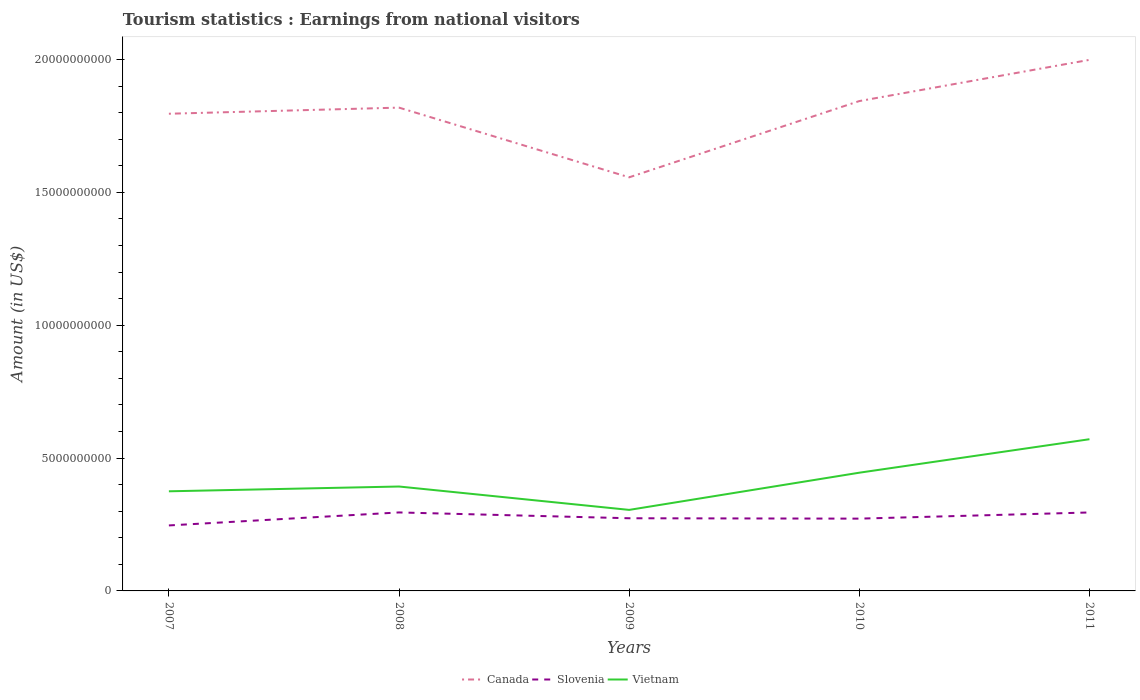How many different coloured lines are there?
Your answer should be very brief. 3. Is the number of lines equal to the number of legend labels?
Your answer should be very brief. Yes. Across all years, what is the maximum earnings from national visitors in Vietnam?
Your answer should be very brief. 3.05e+09. What is the total earnings from national visitors in Canada in the graph?
Offer a terse response. -4.77e+08. What is the difference between the highest and the second highest earnings from national visitors in Vietnam?
Your response must be concise. 2.66e+09. What is the difference between the highest and the lowest earnings from national visitors in Canada?
Give a very brief answer. 3. Is the earnings from national visitors in Vietnam strictly greater than the earnings from national visitors in Canada over the years?
Your answer should be very brief. Yes. How many lines are there?
Your answer should be very brief. 3. Are the values on the major ticks of Y-axis written in scientific E-notation?
Make the answer very short. No. What is the title of the graph?
Your answer should be very brief. Tourism statistics : Earnings from national visitors. Does "Mali" appear as one of the legend labels in the graph?
Offer a very short reply. No. What is the label or title of the X-axis?
Give a very brief answer. Years. What is the label or title of the Y-axis?
Your answer should be very brief. Amount (in US$). What is the Amount (in US$) in Canada in 2007?
Your answer should be compact. 1.80e+1. What is the Amount (in US$) of Slovenia in 2007?
Keep it short and to the point. 2.46e+09. What is the Amount (in US$) in Vietnam in 2007?
Give a very brief answer. 3.75e+09. What is the Amount (in US$) in Canada in 2008?
Your answer should be very brief. 1.82e+1. What is the Amount (in US$) in Slovenia in 2008?
Provide a succinct answer. 2.95e+09. What is the Amount (in US$) in Vietnam in 2008?
Offer a terse response. 3.93e+09. What is the Amount (in US$) of Canada in 2009?
Your answer should be compact. 1.56e+1. What is the Amount (in US$) of Slovenia in 2009?
Offer a very short reply. 2.74e+09. What is the Amount (in US$) in Vietnam in 2009?
Give a very brief answer. 3.05e+09. What is the Amount (in US$) in Canada in 2010?
Ensure brevity in your answer.  1.84e+1. What is the Amount (in US$) in Slovenia in 2010?
Offer a very short reply. 2.72e+09. What is the Amount (in US$) in Vietnam in 2010?
Your response must be concise. 4.45e+09. What is the Amount (in US$) of Canada in 2011?
Your answer should be very brief. 2.00e+1. What is the Amount (in US$) in Slovenia in 2011?
Provide a short and direct response. 2.95e+09. What is the Amount (in US$) in Vietnam in 2011?
Offer a terse response. 5.71e+09. Across all years, what is the maximum Amount (in US$) of Canada?
Make the answer very short. 2.00e+1. Across all years, what is the maximum Amount (in US$) in Slovenia?
Offer a terse response. 2.95e+09. Across all years, what is the maximum Amount (in US$) in Vietnam?
Your answer should be very brief. 5.71e+09. Across all years, what is the minimum Amount (in US$) of Canada?
Your answer should be very brief. 1.56e+1. Across all years, what is the minimum Amount (in US$) in Slovenia?
Your response must be concise. 2.46e+09. Across all years, what is the minimum Amount (in US$) in Vietnam?
Provide a succinct answer. 3.05e+09. What is the total Amount (in US$) in Canada in the graph?
Your answer should be very brief. 9.01e+1. What is the total Amount (in US$) in Slovenia in the graph?
Offer a terse response. 1.38e+1. What is the total Amount (in US$) of Vietnam in the graph?
Give a very brief answer. 2.09e+1. What is the difference between the Amount (in US$) of Canada in 2007 and that in 2008?
Your answer should be very brief. -2.30e+08. What is the difference between the Amount (in US$) of Slovenia in 2007 and that in 2008?
Your response must be concise. -4.89e+08. What is the difference between the Amount (in US$) in Vietnam in 2007 and that in 2008?
Your answer should be very brief. -1.80e+08. What is the difference between the Amount (in US$) of Canada in 2007 and that in 2009?
Give a very brief answer. 2.39e+09. What is the difference between the Amount (in US$) in Slovenia in 2007 and that in 2009?
Your response must be concise. -2.70e+08. What is the difference between the Amount (in US$) in Vietnam in 2007 and that in 2009?
Give a very brief answer. 7.00e+08. What is the difference between the Amount (in US$) in Canada in 2007 and that in 2010?
Provide a short and direct response. -4.77e+08. What is the difference between the Amount (in US$) in Slovenia in 2007 and that in 2010?
Make the answer very short. -2.56e+08. What is the difference between the Amount (in US$) of Vietnam in 2007 and that in 2010?
Your response must be concise. -7.00e+08. What is the difference between the Amount (in US$) in Canada in 2007 and that in 2011?
Your response must be concise. -2.03e+09. What is the difference between the Amount (in US$) in Slovenia in 2007 and that in 2011?
Your answer should be compact. -4.88e+08. What is the difference between the Amount (in US$) in Vietnam in 2007 and that in 2011?
Give a very brief answer. -1.96e+09. What is the difference between the Amount (in US$) in Canada in 2008 and that in 2009?
Ensure brevity in your answer.  2.62e+09. What is the difference between the Amount (in US$) of Slovenia in 2008 and that in 2009?
Give a very brief answer. 2.19e+08. What is the difference between the Amount (in US$) of Vietnam in 2008 and that in 2009?
Give a very brief answer. 8.80e+08. What is the difference between the Amount (in US$) in Canada in 2008 and that in 2010?
Keep it short and to the point. -2.47e+08. What is the difference between the Amount (in US$) of Slovenia in 2008 and that in 2010?
Your answer should be compact. 2.33e+08. What is the difference between the Amount (in US$) in Vietnam in 2008 and that in 2010?
Your answer should be compact. -5.20e+08. What is the difference between the Amount (in US$) in Canada in 2008 and that in 2011?
Provide a succinct answer. -1.80e+09. What is the difference between the Amount (in US$) of Vietnam in 2008 and that in 2011?
Give a very brief answer. -1.78e+09. What is the difference between the Amount (in US$) of Canada in 2009 and that in 2010?
Keep it short and to the point. -2.87e+09. What is the difference between the Amount (in US$) in Slovenia in 2009 and that in 2010?
Your response must be concise. 1.40e+07. What is the difference between the Amount (in US$) of Vietnam in 2009 and that in 2010?
Your answer should be compact. -1.40e+09. What is the difference between the Amount (in US$) in Canada in 2009 and that in 2011?
Make the answer very short. -4.42e+09. What is the difference between the Amount (in US$) of Slovenia in 2009 and that in 2011?
Your answer should be very brief. -2.18e+08. What is the difference between the Amount (in US$) in Vietnam in 2009 and that in 2011?
Ensure brevity in your answer.  -2.66e+09. What is the difference between the Amount (in US$) in Canada in 2010 and that in 2011?
Provide a succinct answer. -1.55e+09. What is the difference between the Amount (in US$) in Slovenia in 2010 and that in 2011?
Ensure brevity in your answer.  -2.32e+08. What is the difference between the Amount (in US$) in Vietnam in 2010 and that in 2011?
Provide a succinct answer. -1.26e+09. What is the difference between the Amount (in US$) in Canada in 2007 and the Amount (in US$) in Slovenia in 2008?
Provide a short and direct response. 1.50e+1. What is the difference between the Amount (in US$) of Canada in 2007 and the Amount (in US$) of Vietnam in 2008?
Offer a very short reply. 1.40e+1. What is the difference between the Amount (in US$) of Slovenia in 2007 and the Amount (in US$) of Vietnam in 2008?
Your response must be concise. -1.46e+09. What is the difference between the Amount (in US$) of Canada in 2007 and the Amount (in US$) of Slovenia in 2009?
Provide a short and direct response. 1.52e+1. What is the difference between the Amount (in US$) of Canada in 2007 and the Amount (in US$) of Vietnam in 2009?
Offer a terse response. 1.49e+1. What is the difference between the Amount (in US$) in Slovenia in 2007 and the Amount (in US$) in Vietnam in 2009?
Your response must be concise. -5.85e+08. What is the difference between the Amount (in US$) of Canada in 2007 and the Amount (in US$) of Slovenia in 2010?
Make the answer very short. 1.52e+1. What is the difference between the Amount (in US$) in Canada in 2007 and the Amount (in US$) in Vietnam in 2010?
Provide a short and direct response. 1.35e+1. What is the difference between the Amount (in US$) of Slovenia in 2007 and the Amount (in US$) of Vietnam in 2010?
Give a very brief answer. -1.98e+09. What is the difference between the Amount (in US$) of Canada in 2007 and the Amount (in US$) of Slovenia in 2011?
Offer a terse response. 1.50e+1. What is the difference between the Amount (in US$) of Canada in 2007 and the Amount (in US$) of Vietnam in 2011?
Make the answer very short. 1.23e+1. What is the difference between the Amount (in US$) of Slovenia in 2007 and the Amount (in US$) of Vietnam in 2011?
Provide a short and direct response. -3.24e+09. What is the difference between the Amount (in US$) in Canada in 2008 and the Amount (in US$) in Slovenia in 2009?
Your answer should be very brief. 1.55e+1. What is the difference between the Amount (in US$) in Canada in 2008 and the Amount (in US$) in Vietnam in 2009?
Ensure brevity in your answer.  1.51e+1. What is the difference between the Amount (in US$) in Slovenia in 2008 and the Amount (in US$) in Vietnam in 2009?
Make the answer very short. -9.60e+07. What is the difference between the Amount (in US$) of Canada in 2008 and the Amount (in US$) of Slovenia in 2010?
Give a very brief answer. 1.55e+1. What is the difference between the Amount (in US$) of Canada in 2008 and the Amount (in US$) of Vietnam in 2010?
Your answer should be compact. 1.37e+1. What is the difference between the Amount (in US$) in Slovenia in 2008 and the Amount (in US$) in Vietnam in 2010?
Offer a very short reply. -1.50e+09. What is the difference between the Amount (in US$) in Canada in 2008 and the Amount (in US$) in Slovenia in 2011?
Ensure brevity in your answer.  1.52e+1. What is the difference between the Amount (in US$) in Canada in 2008 and the Amount (in US$) in Vietnam in 2011?
Ensure brevity in your answer.  1.25e+1. What is the difference between the Amount (in US$) in Slovenia in 2008 and the Amount (in US$) in Vietnam in 2011?
Provide a succinct answer. -2.76e+09. What is the difference between the Amount (in US$) in Canada in 2009 and the Amount (in US$) in Slovenia in 2010?
Make the answer very short. 1.28e+1. What is the difference between the Amount (in US$) in Canada in 2009 and the Amount (in US$) in Vietnam in 2010?
Keep it short and to the point. 1.11e+1. What is the difference between the Amount (in US$) of Slovenia in 2009 and the Amount (in US$) of Vietnam in 2010?
Provide a short and direct response. -1.72e+09. What is the difference between the Amount (in US$) in Canada in 2009 and the Amount (in US$) in Slovenia in 2011?
Provide a short and direct response. 1.26e+1. What is the difference between the Amount (in US$) of Canada in 2009 and the Amount (in US$) of Vietnam in 2011?
Make the answer very short. 9.86e+09. What is the difference between the Amount (in US$) in Slovenia in 2009 and the Amount (in US$) in Vietnam in 2011?
Ensure brevity in your answer.  -2.98e+09. What is the difference between the Amount (in US$) of Canada in 2010 and the Amount (in US$) of Slovenia in 2011?
Give a very brief answer. 1.55e+1. What is the difference between the Amount (in US$) of Canada in 2010 and the Amount (in US$) of Vietnam in 2011?
Your answer should be very brief. 1.27e+1. What is the difference between the Amount (in US$) of Slovenia in 2010 and the Amount (in US$) of Vietnam in 2011?
Keep it short and to the point. -2.99e+09. What is the average Amount (in US$) in Canada per year?
Offer a terse response. 1.80e+1. What is the average Amount (in US$) of Slovenia per year?
Your answer should be very brief. 2.77e+09. What is the average Amount (in US$) of Vietnam per year?
Give a very brief answer. 4.18e+09. In the year 2007, what is the difference between the Amount (in US$) of Canada and Amount (in US$) of Slovenia?
Provide a short and direct response. 1.55e+1. In the year 2007, what is the difference between the Amount (in US$) in Canada and Amount (in US$) in Vietnam?
Your answer should be very brief. 1.42e+1. In the year 2007, what is the difference between the Amount (in US$) of Slovenia and Amount (in US$) of Vietnam?
Make the answer very short. -1.28e+09. In the year 2008, what is the difference between the Amount (in US$) in Canada and Amount (in US$) in Slovenia?
Offer a very short reply. 1.52e+1. In the year 2008, what is the difference between the Amount (in US$) in Canada and Amount (in US$) in Vietnam?
Offer a very short reply. 1.43e+1. In the year 2008, what is the difference between the Amount (in US$) in Slovenia and Amount (in US$) in Vietnam?
Your answer should be very brief. -9.76e+08. In the year 2009, what is the difference between the Amount (in US$) in Canada and Amount (in US$) in Slovenia?
Give a very brief answer. 1.28e+1. In the year 2009, what is the difference between the Amount (in US$) of Canada and Amount (in US$) of Vietnam?
Your answer should be very brief. 1.25e+1. In the year 2009, what is the difference between the Amount (in US$) of Slovenia and Amount (in US$) of Vietnam?
Ensure brevity in your answer.  -3.15e+08. In the year 2010, what is the difference between the Amount (in US$) in Canada and Amount (in US$) in Slovenia?
Give a very brief answer. 1.57e+1. In the year 2010, what is the difference between the Amount (in US$) in Canada and Amount (in US$) in Vietnam?
Give a very brief answer. 1.40e+1. In the year 2010, what is the difference between the Amount (in US$) in Slovenia and Amount (in US$) in Vietnam?
Provide a succinct answer. -1.73e+09. In the year 2011, what is the difference between the Amount (in US$) of Canada and Amount (in US$) of Slovenia?
Keep it short and to the point. 1.70e+1. In the year 2011, what is the difference between the Amount (in US$) in Canada and Amount (in US$) in Vietnam?
Your answer should be very brief. 1.43e+1. In the year 2011, what is the difference between the Amount (in US$) of Slovenia and Amount (in US$) of Vietnam?
Your response must be concise. -2.76e+09. What is the ratio of the Amount (in US$) of Canada in 2007 to that in 2008?
Ensure brevity in your answer.  0.99. What is the ratio of the Amount (in US$) of Slovenia in 2007 to that in 2008?
Keep it short and to the point. 0.83. What is the ratio of the Amount (in US$) in Vietnam in 2007 to that in 2008?
Offer a very short reply. 0.95. What is the ratio of the Amount (in US$) in Canada in 2007 to that in 2009?
Provide a succinct answer. 1.15. What is the ratio of the Amount (in US$) in Slovenia in 2007 to that in 2009?
Ensure brevity in your answer.  0.9. What is the ratio of the Amount (in US$) of Vietnam in 2007 to that in 2009?
Make the answer very short. 1.23. What is the ratio of the Amount (in US$) in Canada in 2007 to that in 2010?
Make the answer very short. 0.97. What is the ratio of the Amount (in US$) of Slovenia in 2007 to that in 2010?
Give a very brief answer. 0.91. What is the ratio of the Amount (in US$) in Vietnam in 2007 to that in 2010?
Make the answer very short. 0.84. What is the ratio of the Amount (in US$) of Canada in 2007 to that in 2011?
Provide a short and direct response. 0.9. What is the ratio of the Amount (in US$) of Slovenia in 2007 to that in 2011?
Provide a succinct answer. 0.83. What is the ratio of the Amount (in US$) of Vietnam in 2007 to that in 2011?
Provide a succinct answer. 0.66. What is the ratio of the Amount (in US$) of Canada in 2008 to that in 2009?
Your answer should be very brief. 1.17. What is the ratio of the Amount (in US$) of Slovenia in 2008 to that in 2009?
Offer a terse response. 1.08. What is the ratio of the Amount (in US$) of Vietnam in 2008 to that in 2009?
Provide a short and direct response. 1.29. What is the ratio of the Amount (in US$) of Canada in 2008 to that in 2010?
Offer a terse response. 0.99. What is the ratio of the Amount (in US$) in Slovenia in 2008 to that in 2010?
Provide a succinct answer. 1.09. What is the ratio of the Amount (in US$) in Vietnam in 2008 to that in 2010?
Your answer should be very brief. 0.88. What is the ratio of the Amount (in US$) in Canada in 2008 to that in 2011?
Keep it short and to the point. 0.91. What is the ratio of the Amount (in US$) of Vietnam in 2008 to that in 2011?
Your answer should be compact. 0.69. What is the ratio of the Amount (in US$) of Canada in 2009 to that in 2010?
Your answer should be very brief. 0.84. What is the ratio of the Amount (in US$) in Vietnam in 2009 to that in 2010?
Provide a short and direct response. 0.69. What is the ratio of the Amount (in US$) of Canada in 2009 to that in 2011?
Offer a very short reply. 0.78. What is the ratio of the Amount (in US$) of Slovenia in 2009 to that in 2011?
Provide a short and direct response. 0.93. What is the ratio of the Amount (in US$) of Vietnam in 2009 to that in 2011?
Your answer should be compact. 0.53. What is the ratio of the Amount (in US$) of Canada in 2010 to that in 2011?
Keep it short and to the point. 0.92. What is the ratio of the Amount (in US$) of Slovenia in 2010 to that in 2011?
Give a very brief answer. 0.92. What is the ratio of the Amount (in US$) in Vietnam in 2010 to that in 2011?
Give a very brief answer. 0.78. What is the difference between the highest and the second highest Amount (in US$) of Canada?
Your response must be concise. 1.55e+09. What is the difference between the highest and the second highest Amount (in US$) in Slovenia?
Your answer should be compact. 1.00e+06. What is the difference between the highest and the second highest Amount (in US$) of Vietnam?
Provide a short and direct response. 1.26e+09. What is the difference between the highest and the lowest Amount (in US$) of Canada?
Ensure brevity in your answer.  4.42e+09. What is the difference between the highest and the lowest Amount (in US$) in Slovenia?
Give a very brief answer. 4.89e+08. What is the difference between the highest and the lowest Amount (in US$) of Vietnam?
Make the answer very short. 2.66e+09. 